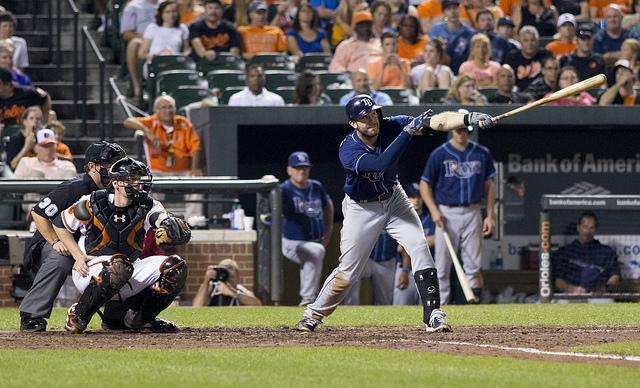How many people are in the photo?
Give a very brief answer. 8. 